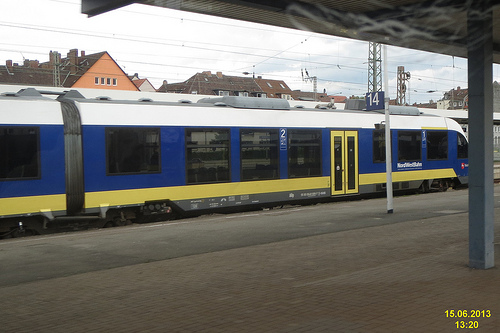Is the tower that is to the right of the other tower made of brick?
Answer the question using a single word or phrase. No Is there any train to the right of the tower made of metal? No Are there both a fence and a train in the photograph? No Are there trains in front of the tower that is to the right of the house? Yes How is the weather? Cloudy Which place is it? Train station Is there a fence or a train in this image? Yes Are there both a window and a door in this picture? Yes What color is the house on the left side? Orange Are there buses or cars in this photo? Yes Are there both a window and a door in the image? Yes Is this place a train station or an airport? Train station 